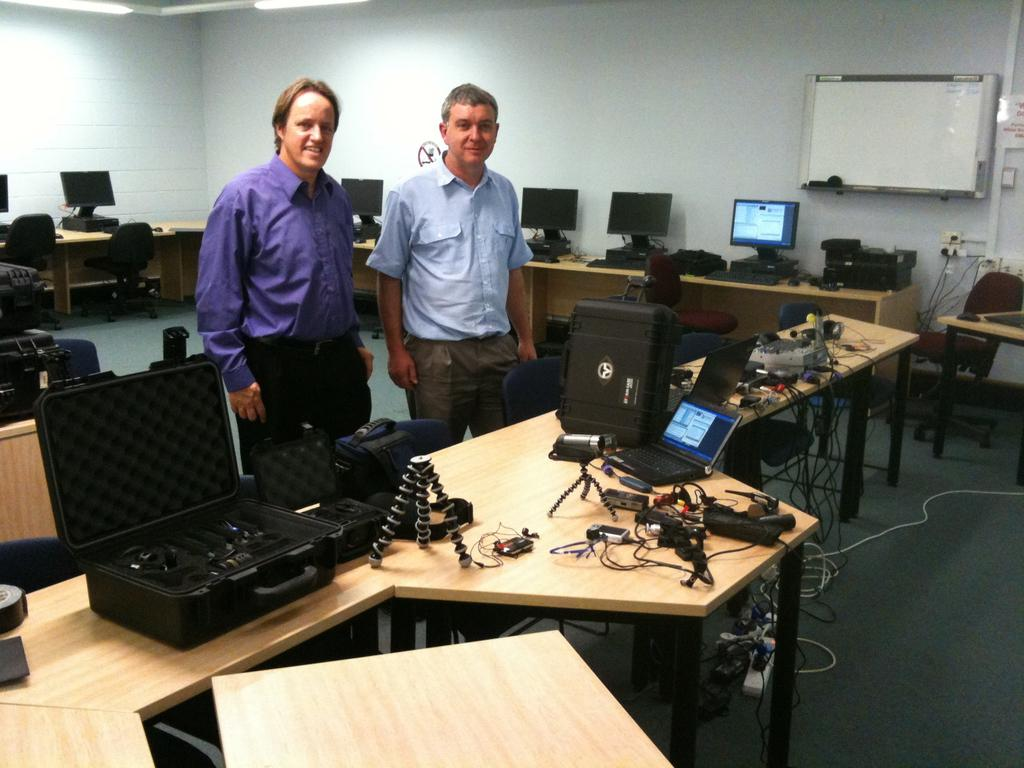How many people are in the image? There are two men in the image. What are the men doing in the image? The men are standing behind a table. What can be seen on the table in the image? There are electronic gadgets on the table. Are there any chairs in the image? Yes, there are empty chairs in the image. What type of anger can be seen on the faces of the men in the image? There is no indication of anger on the faces of the men in the image; they appear to be standing calmly behind the table. What type of learning is taking place in the image? There is no indication of learning or any educational activity in the image; it simply shows two men standing behind a table with electronic gadgets. 